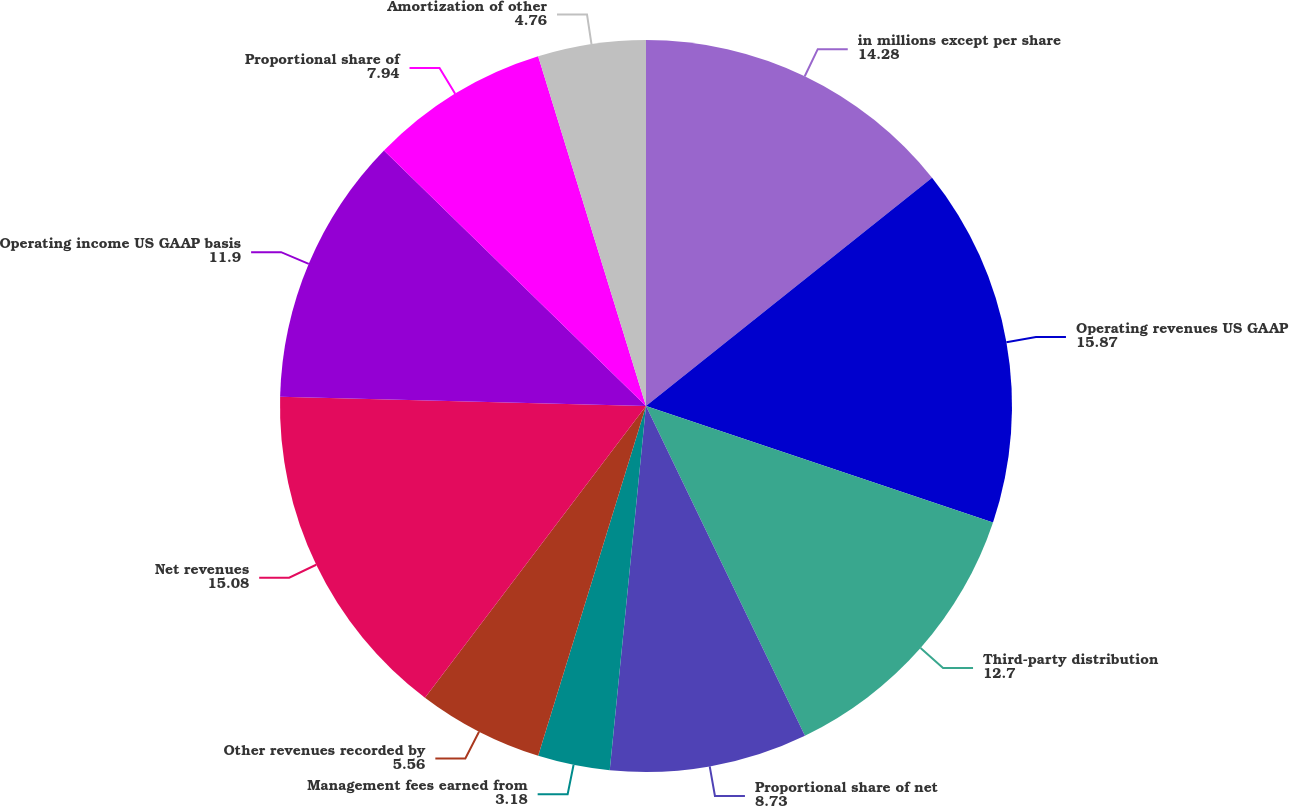Convert chart. <chart><loc_0><loc_0><loc_500><loc_500><pie_chart><fcel>in millions except per share<fcel>Operating revenues US GAAP<fcel>Third-party distribution<fcel>Proportional share of net<fcel>Management fees earned from<fcel>Other revenues recorded by<fcel>Net revenues<fcel>Operating income US GAAP basis<fcel>Proportional share of<fcel>Amortization of other<nl><fcel>14.28%<fcel>15.87%<fcel>12.7%<fcel>8.73%<fcel>3.18%<fcel>5.56%<fcel>15.08%<fcel>11.9%<fcel>7.94%<fcel>4.76%<nl></chart> 